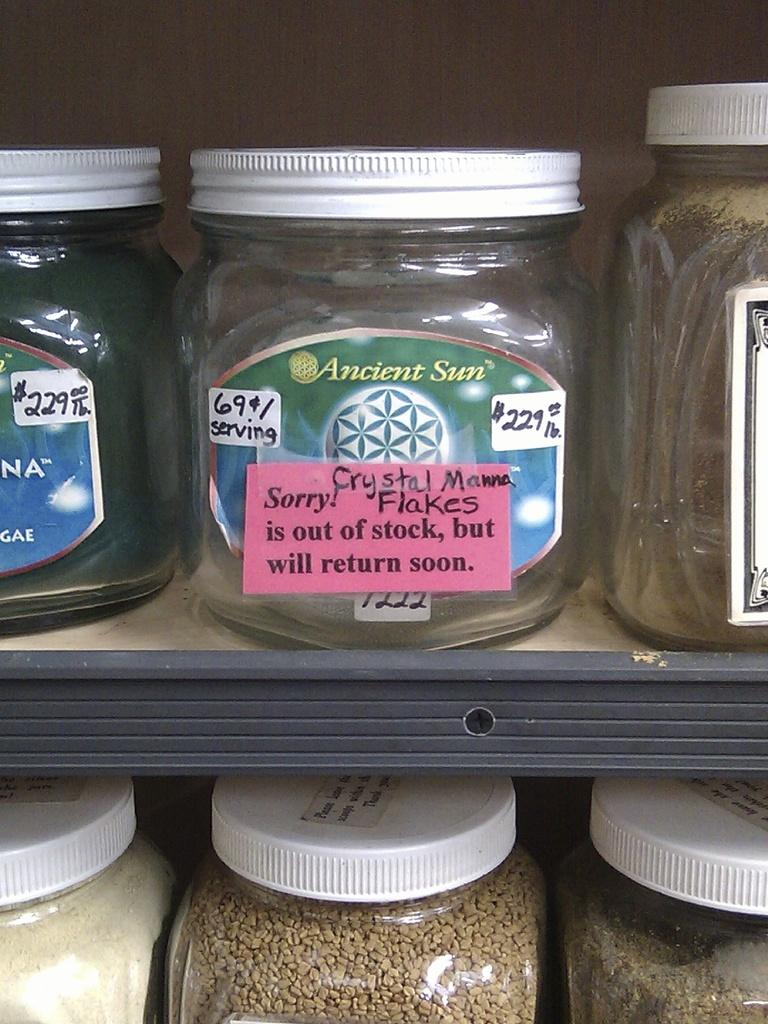What type of containers are visible in the image? There are glass jars in the image. What can be found inside the glass jars? The glass jars have something inside them. Can you see any swings on the island in the image? There is no island or swing present in the image; it only features glass jars with something inside them. How many snails are crawling on the glass jars in the image? There are no snails visible in the image; it only features glass jars with something inside them. 